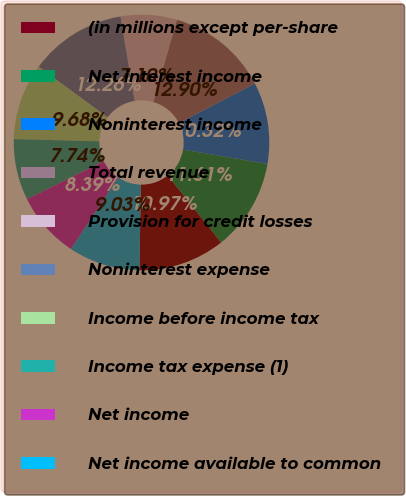<chart> <loc_0><loc_0><loc_500><loc_500><pie_chart><fcel>(in millions except per-share<fcel>Net interest income<fcel>Noninterest income<fcel>Total revenue<fcel>Provision for credit losses<fcel>Noninterest expense<fcel>Income before income tax<fcel>Income tax expense (1)<fcel>Net income<fcel>Net income available to common<nl><fcel>10.97%<fcel>11.61%<fcel>10.32%<fcel>12.9%<fcel>7.1%<fcel>12.26%<fcel>9.68%<fcel>7.74%<fcel>8.39%<fcel>9.03%<nl></chart> 